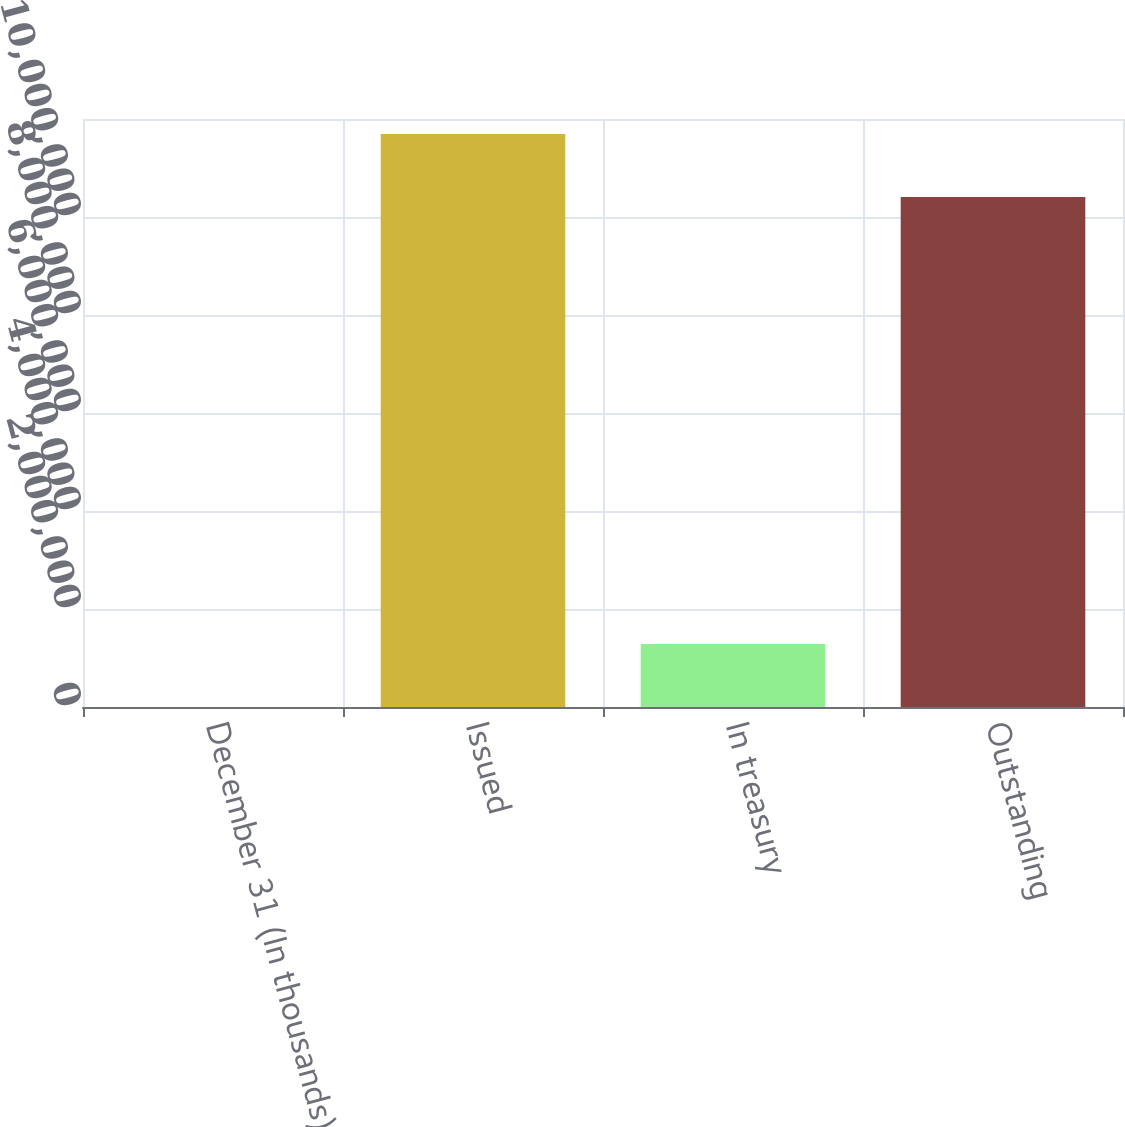Convert chart. <chart><loc_0><loc_0><loc_500><loc_500><bar_chart><fcel>December 31 (In thousands)<fcel>Issued<fcel>In treasury<fcel>Outstanding<nl><fcel>2012<fcel>1.16938e+07<fcel>1.28822e+06<fcel>1.04056e+07<nl></chart> 